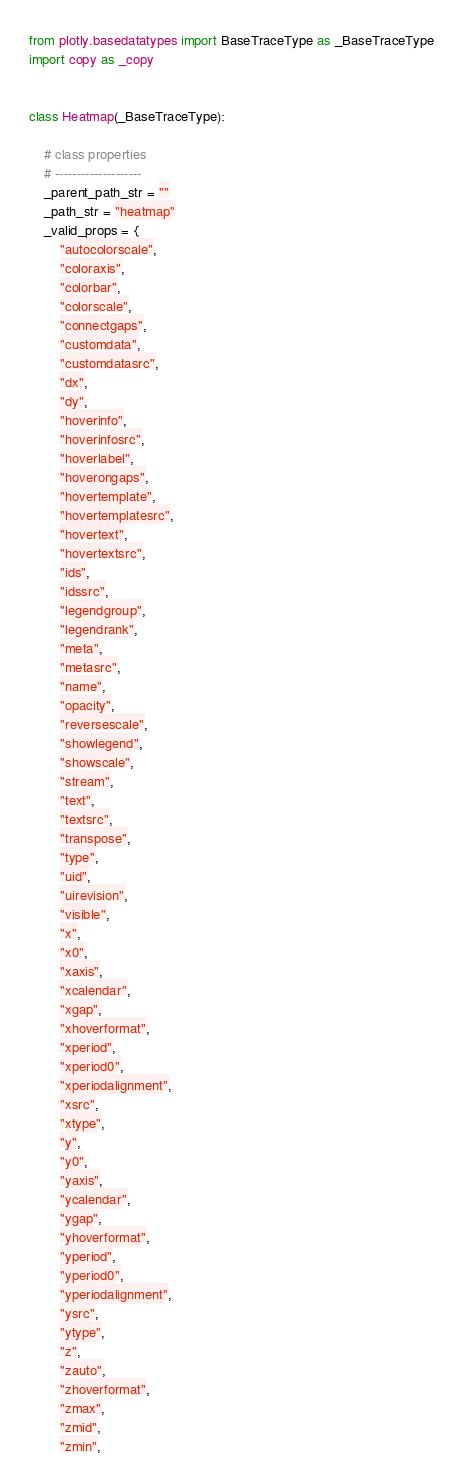<code> <loc_0><loc_0><loc_500><loc_500><_Python_>from plotly.basedatatypes import BaseTraceType as _BaseTraceType
import copy as _copy


class Heatmap(_BaseTraceType):

    # class properties
    # --------------------
    _parent_path_str = ""
    _path_str = "heatmap"
    _valid_props = {
        "autocolorscale",
        "coloraxis",
        "colorbar",
        "colorscale",
        "connectgaps",
        "customdata",
        "customdatasrc",
        "dx",
        "dy",
        "hoverinfo",
        "hoverinfosrc",
        "hoverlabel",
        "hoverongaps",
        "hovertemplate",
        "hovertemplatesrc",
        "hovertext",
        "hovertextsrc",
        "ids",
        "idssrc",
        "legendgroup",
        "legendrank",
        "meta",
        "metasrc",
        "name",
        "opacity",
        "reversescale",
        "showlegend",
        "showscale",
        "stream",
        "text",
        "textsrc",
        "transpose",
        "type",
        "uid",
        "uirevision",
        "visible",
        "x",
        "x0",
        "xaxis",
        "xcalendar",
        "xgap",
        "xhoverformat",
        "xperiod",
        "xperiod0",
        "xperiodalignment",
        "xsrc",
        "xtype",
        "y",
        "y0",
        "yaxis",
        "ycalendar",
        "ygap",
        "yhoverformat",
        "yperiod",
        "yperiod0",
        "yperiodalignment",
        "ysrc",
        "ytype",
        "z",
        "zauto",
        "zhoverformat",
        "zmax",
        "zmid",
        "zmin",</code> 